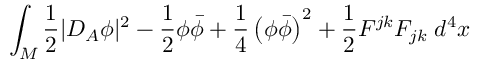Convert formula to latex. <formula><loc_0><loc_0><loc_500><loc_500>\int _ { M } \frac { 1 } { 2 } | D _ { A } \phi | ^ { 2 } - \frac { 1 } { 2 } \phi \bar { \phi } + \frac { 1 } { 4 } \left ( \phi \bar { \phi } \right ) ^ { 2 } + \frac { 1 } { 2 } F ^ { j k } F _ { j k } \, d ^ { 4 } x</formula> 